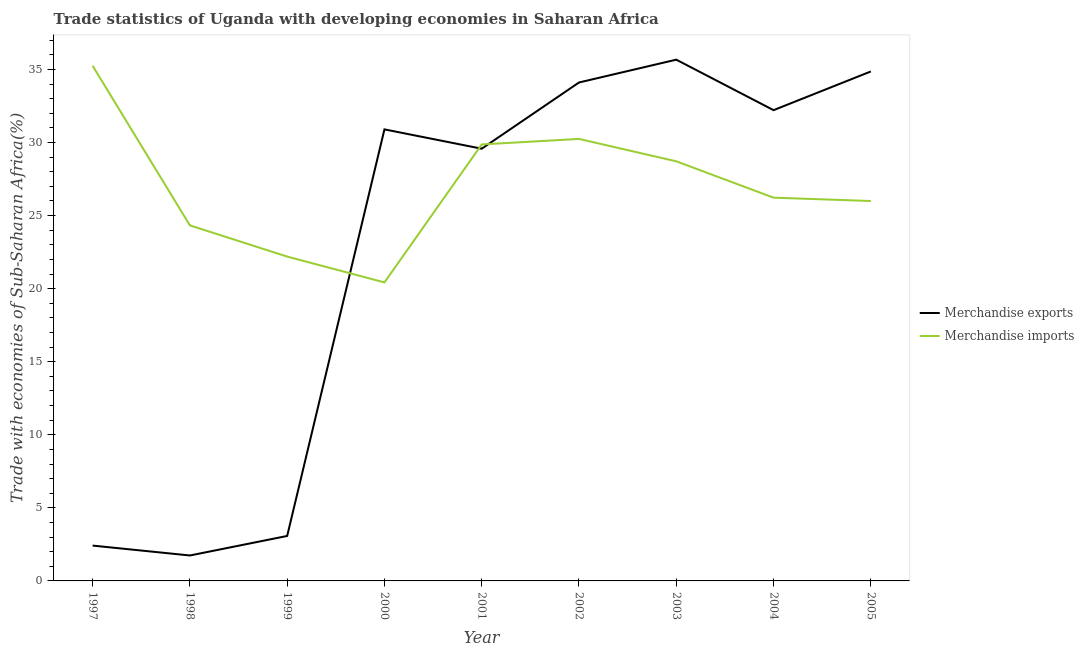How many different coloured lines are there?
Keep it short and to the point. 2. Does the line corresponding to merchandise imports intersect with the line corresponding to merchandise exports?
Make the answer very short. Yes. What is the merchandise imports in 2002?
Give a very brief answer. 30.24. Across all years, what is the maximum merchandise imports?
Provide a succinct answer. 35.25. Across all years, what is the minimum merchandise exports?
Your response must be concise. 1.74. In which year was the merchandise imports maximum?
Ensure brevity in your answer.  1997. In which year was the merchandise imports minimum?
Offer a terse response. 2000. What is the total merchandise exports in the graph?
Your response must be concise. 204.54. What is the difference between the merchandise imports in 1998 and that in 2002?
Offer a very short reply. -5.92. What is the difference between the merchandise exports in 1998 and the merchandise imports in 2001?
Provide a short and direct response. -28.13. What is the average merchandise exports per year?
Make the answer very short. 22.73. In the year 2004, what is the difference between the merchandise exports and merchandise imports?
Make the answer very short. 5.99. In how many years, is the merchandise imports greater than 7 %?
Give a very brief answer. 9. What is the ratio of the merchandise imports in 2001 to that in 2005?
Offer a very short reply. 1.15. What is the difference between the highest and the second highest merchandise exports?
Offer a terse response. 0.81. What is the difference between the highest and the lowest merchandise imports?
Your answer should be compact. 14.82. Does the merchandise imports monotonically increase over the years?
Provide a succinct answer. No. Is the merchandise imports strictly greater than the merchandise exports over the years?
Offer a very short reply. No. Is the merchandise imports strictly less than the merchandise exports over the years?
Give a very brief answer. No. How many years are there in the graph?
Ensure brevity in your answer.  9. What is the difference between two consecutive major ticks on the Y-axis?
Provide a succinct answer. 5. Are the values on the major ticks of Y-axis written in scientific E-notation?
Keep it short and to the point. No. Does the graph contain grids?
Your answer should be very brief. No. Where does the legend appear in the graph?
Ensure brevity in your answer.  Center right. How many legend labels are there?
Your answer should be very brief. 2. What is the title of the graph?
Provide a succinct answer. Trade statistics of Uganda with developing economies in Saharan Africa. What is the label or title of the X-axis?
Your response must be concise. Year. What is the label or title of the Y-axis?
Your response must be concise. Trade with economies of Sub-Saharan Africa(%). What is the Trade with economies of Sub-Saharan Africa(%) in Merchandise exports in 1997?
Your response must be concise. 2.42. What is the Trade with economies of Sub-Saharan Africa(%) in Merchandise imports in 1997?
Ensure brevity in your answer.  35.25. What is the Trade with economies of Sub-Saharan Africa(%) in Merchandise exports in 1998?
Offer a very short reply. 1.74. What is the Trade with economies of Sub-Saharan Africa(%) of Merchandise imports in 1998?
Give a very brief answer. 24.33. What is the Trade with economies of Sub-Saharan Africa(%) of Merchandise exports in 1999?
Give a very brief answer. 3.08. What is the Trade with economies of Sub-Saharan Africa(%) in Merchandise imports in 1999?
Make the answer very short. 22.19. What is the Trade with economies of Sub-Saharan Africa(%) in Merchandise exports in 2000?
Offer a very short reply. 30.9. What is the Trade with economies of Sub-Saharan Africa(%) in Merchandise imports in 2000?
Ensure brevity in your answer.  20.43. What is the Trade with economies of Sub-Saharan Africa(%) in Merchandise exports in 2001?
Provide a succinct answer. 29.57. What is the Trade with economies of Sub-Saharan Africa(%) in Merchandise imports in 2001?
Offer a very short reply. 29.87. What is the Trade with economies of Sub-Saharan Africa(%) of Merchandise exports in 2002?
Offer a very short reply. 34.1. What is the Trade with economies of Sub-Saharan Africa(%) of Merchandise imports in 2002?
Keep it short and to the point. 30.24. What is the Trade with economies of Sub-Saharan Africa(%) in Merchandise exports in 2003?
Give a very brief answer. 35.67. What is the Trade with economies of Sub-Saharan Africa(%) of Merchandise imports in 2003?
Offer a terse response. 28.71. What is the Trade with economies of Sub-Saharan Africa(%) in Merchandise exports in 2004?
Keep it short and to the point. 32.21. What is the Trade with economies of Sub-Saharan Africa(%) of Merchandise imports in 2004?
Ensure brevity in your answer.  26.22. What is the Trade with economies of Sub-Saharan Africa(%) of Merchandise exports in 2005?
Keep it short and to the point. 34.86. What is the Trade with economies of Sub-Saharan Africa(%) in Merchandise imports in 2005?
Offer a terse response. 25.99. Across all years, what is the maximum Trade with economies of Sub-Saharan Africa(%) of Merchandise exports?
Your response must be concise. 35.67. Across all years, what is the maximum Trade with economies of Sub-Saharan Africa(%) of Merchandise imports?
Your answer should be very brief. 35.25. Across all years, what is the minimum Trade with economies of Sub-Saharan Africa(%) of Merchandise exports?
Your answer should be very brief. 1.74. Across all years, what is the minimum Trade with economies of Sub-Saharan Africa(%) in Merchandise imports?
Offer a very short reply. 20.43. What is the total Trade with economies of Sub-Saharan Africa(%) in Merchandise exports in the graph?
Give a very brief answer. 204.54. What is the total Trade with economies of Sub-Saharan Africa(%) in Merchandise imports in the graph?
Keep it short and to the point. 243.23. What is the difference between the Trade with economies of Sub-Saharan Africa(%) of Merchandise exports in 1997 and that in 1998?
Make the answer very short. 0.68. What is the difference between the Trade with economies of Sub-Saharan Africa(%) of Merchandise imports in 1997 and that in 1998?
Give a very brief answer. 10.92. What is the difference between the Trade with economies of Sub-Saharan Africa(%) in Merchandise exports in 1997 and that in 1999?
Make the answer very short. -0.66. What is the difference between the Trade with economies of Sub-Saharan Africa(%) in Merchandise imports in 1997 and that in 1999?
Provide a short and direct response. 13.05. What is the difference between the Trade with economies of Sub-Saharan Africa(%) in Merchandise exports in 1997 and that in 2000?
Your answer should be compact. -28.48. What is the difference between the Trade with economies of Sub-Saharan Africa(%) in Merchandise imports in 1997 and that in 2000?
Provide a succinct answer. 14.82. What is the difference between the Trade with economies of Sub-Saharan Africa(%) in Merchandise exports in 1997 and that in 2001?
Your response must be concise. -27.16. What is the difference between the Trade with economies of Sub-Saharan Africa(%) of Merchandise imports in 1997 and that in 2001?
Your response must be concise. 5.38. What is the difference between the Trade with economies of Sub-Saharan Africa(%) of Merchandise exports in 1997 and that in 2002?
Provide a succinct answer. -31.69. What is the difference between the Trade with economies of Sub-Saharan Africa(%) in Merchandise imports in 1997 and that in 2002?
Make the answer very short. 5. What is the difference between the Trade with economies of Sub-Saharan Africa(%) of Merchandise exports in 1997 and that in 2003?
Your answer should be compact. -33.25. What is the difference between the Trade with economies of Sub-Saharan Africa(%) of Merchandise imports in 1997 and that in 2003?
Your response must be concise. 6.54. What is the difference between the Trade with economies of Sub-Saharan Africa(%) in Merchandise exports in 1997 and that in 2004?
Your answer should be compact. -29.79. What is the difference between the Trade with economies of Sub-Saharan Africa(%) of Merchandise imports in 1997 and that in 2004?
Offer a very short reply. 9.02. What is the difference between the Trade with economies of Sub-Saharan Africa(%) in Merchandise exports in 1997 and that in 2005?
Make the answer very short. -32.44. What is the difference between the Trade with economies of Sub-Saharan Africa(%) of Merchandise imports in 1997 and that in 2005?
Provide a short and direct response. 9.25. What is the difference between the Trade with economies of Sub-Saharan Africa(%) in Merchandise exports in 1998 and that in 1999?
Keep it short and to the point. -1.34. What is the difference between the Trade with economies of Sub-Saharan Africa(%) in Merchandise imports in 1998 and that in 1999?
Keep it short and to the point. 2.13. What is the difference between the Trade with economies of Sub-Saharan Africa(%) in Merchandise exports in 1998 and that in 2000?
Give a very brief answer. -29.16. What is the difference between the Trade with economies of Sub-Saharan Africa(%) of Merchandise imports in 1998 and that in 2000?
Provide a short and direct response. 3.9. What is the difference between the Trade with economies of Sub-Saharan Africa(%) in Merchandise exports in 1998 and that in 2001?
Your answer should be very brief. -27.83. What is the difference between the Trade with economies of Sub-Saharan Africa(%) in Merchandise imports in 1998 and that in 2001?
Your answer should be very brief. -5.54. What is the difference between the Trade with economies of Sub-Saharan Africa(%) in Merchandise exports in 1998 and that in 2002?
Offer a very short reply. -32.36. What is the difference between the Trade with economies of Sub-Saharan Africa(%) of Merchandise imports in 1998 and that in 2002?
Keep it short and to the point. -5.92. What is the difference between the Trade with economies of Sub-Saharan Africa(%) of Merchandise exports in 1998 and that in 2003?
Ensure brevity in your answer.  -33.93. What is the difference between the Trade with economies of Sub-Saharan Africa(%) of Merchandise imports in 1998 and that in 2003?
Your response must be concise. -4.38. What is the difference between the Trade with economies of Sub-Saharan Africa(%) in Merchandise exports in 1998 and that in 2004?
Provide a short and direct response. -30.47. What is the difference between the Trade with economies of Sub-Saharan Africa(%) of Merchandise imports in 1998 and that in 2004?
Your answer should be compact. -1.9. What is the difference between the Trade with economies of Sub-Saharan Africa(%) in Merchandise exports in 1998 and that in 2005?
Provide a succinct answer. -33.12. What is the difference between the Trade with economies of Sub-Saharan Africa(%) in Merchandise imports in 1998 and that in 2005?
Offer a very short reply. -1.67. What is the difference between the Trade with economies of Sub-Saharan Africa(%) of Merchandise exports in 1999 and that in 2000?
Provide a short and direct response. -27.82. What is the difference between the Trade with economies of Sub-Saharan Africa(%) in Merchandise imports in 1999 and that in 2000?
Keep it short and to the point. 1.77. What is the difference between the Trade with economies of Sub-Saharan Africa(%) in Merchandise exports in 1999 and that in 2001?
Provide a succinct answer. -26.5. What is the difference between the Trade with economies of Sub-Saharan Africa(%) of Merchandise imports in 1999 and that in 2001?
Offer a very short reply. -7.67. What is the difference between the Trade with economies of Sub-Saharan Africa(%) of Merchandise exports in 1999 and that in 2002?
Ensure brevity in your answer.  -31.03. What is the difference between the Trade with economies of Sub-Saharan Africa(%) of Merchandise imports in 1999 and that in 2002?
Your response must be concise. -8.05. What is the difference between the Trade with economies of Sub-Saharan Africa(%) of Merchandise exports in 1999 and that in 2003?
Your response must be concise. -32.59. What is the difference between the Trade with economies of Sub-Saharan Africa(%) of Merchandise imports in 1999 and that in 2003?
Provide a succinct answer. -6.52. What is the difference between the Trade with economies of Sub-Saharan Africa(%) in Merchandise exports in 1999 and that in 2004?
Your answer should be compact. -29.13. What is the difference between the Trade with economies of Sub-Saharan Africa(%) of Merchandise imports in 1999 and that in 2004?
Your answer should be very brief. -4.03. What is the difference between the Trade with economies of Sub-Saharan Africa(%) of Merchandise exports in 1999 and that in 2005?
Offer a terse response. -31.78. What is the difference between the Trade with economies of Sub-Saharan Africa(%) of Merchandise imports in 1999 and that in 2005?
Ensure brevity in your answer.  -3.8. What is the difference between the Trade with economies of Sub-Saharan Africa(%) of Merchandise exports in 2000 and that in 2001?
Provide a succinct answer. 1.32. What is the difference between the Trade with economies of Sub-Saharan Africa(%) in Merchandise imports in 2000 and that in 2001?
Ensure brevity in your answer.  -9.44. What is the difference between the Trade with economies of Sub-Saharan Africa(%) in Merchandise exports in 2000 and that in 2002?
Keep it short and to the point. -3.21. What is the difference between the Trade with economies of Sub-Saharan Africa(%) in Merchandise imports in 2000 and that in 2002?
Provide a succinct answer. -9.82. What is the difference between the Trade with economies of Sub-Saharan Africa(%) of Merchandise exports in 2000 and that in 2003?
Your answer should be very brief. -4.77. What is the difference between the Trade with economies of Sub-Saharan Africa(%) of Merchandise imports in 2000 and that in 2003?
Provide a succinct answer. -8.29. What is the difference between the Trade with economies of Sub-Saharan Africa(%) in Merchandise exports in 2000 and that in 2004?
Give a very brief answer. -1.31. What is the difference between the Trade with economies of Sub-Saharan Africa(%) in Merchandise imports in 2000 and that in 2004?
Provide a succinct answer. -5.8. What is the difference between the Trade with economies of Sub-Saharan Africa(%) of Merchandise exports in 2000 and that in 2005?
Your answer should be compact. -3.96. What is the difference between the Trade with economies of Sub-Saharan Africa(%) in Merchandise imports in 2000 and that in 2005?
Your answer should be compact. -5.57. What is the difference between the Trade with economies of Sub-Saharan Africa(%) of Merchandise exports in 2001 and that in 2002?
Your response must be concise. -4.53. What is the difference between the Trade with economies of Sub-Saharan Africa(%) of Merchandise imports in 2001 and that in 2002?
Keep it short and to the point. -0.38. What is the difference between the Trade with economies of Sub-Saharan Africa(%) of Merchandise exports in 2001 and that in 2003?
Make the answer very short. -6.09. What is the difference between the Trade with economies of Sub-Saharan Africa(%) in Merchandise imports in 2001 and that in 2003?
Offer a very short reply. 1.16. What is the difference between the Trade with economies of Sub-Saharan Africa(%) in Merchandise exports in 2001 and that in 2004?
Ensure brevity in your answer.  -2.64. What is the difference between the Trade with economies of Sub-Saharan Africa(%) in Merchandise imports in 2001 and that in 2004?
Ensure brevity in your answer.  3.64. What is the difference between the Trade with economies of Sub-Saharan Africa(%) in Merchandise exports in 2001 and that in 2005?
Make the answer very short. -5.29. What is the difference between the Trade with economies of Sub-Saharan Africa(%) in Merchandise imports in 2001 and that in 2005?
Your response must be concise. 3.87. What is the difference between the Trade with economies of Sub-Saharan Africa(%) of Merchandise exports in 2002 and that in 2003?
Provide a short and direct response. -1.56. What is the difference between the Trade with economies of Sub-Saharan Africa(%) of Merchandise imports in 2002 and that in 2003?
Provide a short and direct response. 1.53. What is the difference between the Trade with economies of Sub-Saharan Africa(%) of Merchandise exports in 2002 and that in 2004?
Offer a terse response. 1.89. What is the difference between the Trade with economies of Sub-Saharan Africa(%) of Merchandise imports in 2002 and that in 2004?
Provide a succinct answer. 4.02. What is the difference between the Trade with economies of Sub-Saharan Africa(%) of Merchandise exports in 2002 and that in 2005?
Provide a succinct answer. -0.75. What is the difference between the Trade with economies of Sub-Saharan Africa(%) of Merchandise imports in 2002 and that in 2005?
Your answer should be very brief. 4.25. What is the difference between the Trade with economies of Sub-Saharan Africa(%) in Merchandise exports in 2003 and that in 2004?
Offer a very short reply. 3.45. What is the difference between the Trade with economies of Sub-Saharan Africa(%) of Merchandise imports in 2003 and that in 2004?
Provide a succinct answer. 2.49. What is the difference between the Trade with economies of Sub-Saharan Africa(%) of Merchandise exports in 2003 and that in 2005?
Offer a terse response. 0.81. What is the difference between the Trade with economies of Sub-Saharan Africa(%) in Merchandise imports in 2003 and that in 2005?
Ensure brevity in your answer.  2.72. What is the difference between the Trade with economies of Sub-Saharan Africa(%) of Merchandise exports in 2004 and that in 2005?
Your answer should be very brief. -2.65. What is the difference between the Trade with economies of Sub-Saharan Africa(%) in Merchandise imports in 2004 and that in 2005?
Provide a short and direct response. 0.23. What is the difference between the Trade with economies of Sub-Saharan Africa(%) in Merchandise exports in 1997 and the Trade with economies of Sub-Saharan Africa(%) in Merchandise imports in 1998?
Keep it short and to the point. -21.91. What is the difference between the Trade with economies of Sub-Saharan Africa(%) of Merchandise exports in 1997 and the Trade with economies of Sub-Saharan Africa(%) of Merchandise imports in 1999?
Make the answer very short. -19.77. What is the difference between the Trade with economies of Sub-Saharan Africa(%) of Merchandise exports in 1997 and the Trade with economies of Sub-Saharan Africa(%) of Merchandise imports in 2000?
Keep it short and to the point. -18.01. What is the difference between the Trade with economies of Sub-Saharan Africa(%) in Merchandise exports in 1997 and the Trade with economies of Sub-Saharan Africa(%) in Merchandise imports in 2001?
Give a very brief answer. -27.45. What is the difference between the Trade with economies of Sub-Saharan Africa(%) of Merchandise exports in 1997 and the Trade with economies of Sub-Saharan Africa(%) of Merchandise imports in 2002?
Keep it short and to the point. -27.82. What is the difference between the Trade with economies of Sub-Saharan Africa(%) in Merchandise exports in 1997 and the Trade with economies of Sub-Saharan Africa(%) in Merchandise imports in 2003?
Keep it short and to the point. -26.29. What is the difference between the Trade with economies of Sub-Saharan Africa(%) of Merchandise exports in 1997 and the Trade with economies of Sub-Saharan Africa(%) of Merchandise imports in 2004?
Your response must be concise. -23.81. What is the difference between the Trade with economies of Sub-Saharan Africa(%) in Merchandise exports in 1997 and the Trade with economies of Sub-Saharan Africa(%) in Merchandise imports in 2005?
Keep it short and to the point. -23.58. What is the difference between the Trade with economies of Sub-Saharan Africa(%) in Merchandise exports in 1998 and the Trade with economies of Sub-Saharan Africa(%) in Merchandise imports in 1999?
Keep it short and to the point. -20.45. What is the difference between the Trade with economies of Sub-Saharan Africa(%) of Merchandise exports in 1998 and the Trade with economies of Sub-Saharan Africa(%) of Merchandise imports in 2000?
Your answer should be very brief. -18.68. What is the difference between the Trade with economies of Sub-Saharan Africa(%) in Merchandise exports in 1998 and the Trade with economies of Sub-Saharan Africa(%) in Merchandise imports in 2001?
Your response must be concise. -28.13. What is the difference between the Trade with economies of Sub-Saharan Africa(%) in Merchandise exports in 1998 and the Trade with economies of Sub-Saharan Africa(%) in Merchandise imports in 2002?
Offer a very short reply. -28.5. What is the difference between the Trade with economies of Sub-Saharan Africa(%) in Merchandise exports in 1998 and the Trade with economies of Sub-Saharan Africa(%) in Merchandise imports in 2003?
Offer a terse response. -26.97. What is the difference between the Trade with economies of Sub-Saharan Africa(%) of Merchandise exports in 1998 and the Trade with economies of Sub-Saharan Africa(%) of Merchandise imports in 2004?
Give a very brief answer. -24.48. What is the difference between the Trade with economies of Sub-Saharan Africa(%) in Merchandise exports in 1998 and the Trade with economies of Sub-Saharan Africa(%) in Merchandise imports in 2005?
Your answer should be very brief. -24.25. What is the difference between the Trade with economies of Sub-Saharan Africa(%) of Merchandise exports in 1999 and the Trade with economies of Sub-Saharan Africa(%) of Merchandise imports in 2000?
Provide a succinct answer. -17.35. What is the difference between the Trade with economies of Sub-Saharan Africa(%) of Merchandise exports in 1999 and the Trade with economies of Sub-Saharan Africa(%) of Merchandise imports in 2001?
Offer a terse response. -26.79. What is the difference between the Trade with economies of Sub-Saharan Africa(%) of Merchandise exports in 1999 and the Trade with economies of Sub-Saharan Africa(%) of Merchandise imports in 2002?
Your answer should be very brief. -27.17. What is the difference between the Trade with economies of Sub-Saharan Africa(%) of Merchandise exports in 1999 and the Trade with economies of Sub-Saharan Africa(%) of Merchandise imports in 2003?
Ensure brevity in your answer.  -25.63. What is the difference between the Trade with economies of Sub-Saharan Africa(%) in Merchandise exports in 1999 and the Trade with economies of Sub-Saharan Africa(%) in Merchandise imports in 2004?
Offer a terse response. -23.15. What is the difference between the Trade with economies of Sub-Saharan Africa(%) in Merchandise exports in 1999 and the Trade with economies of Sub-Saharan Africa(%) in Merchandise imports in 2005?
Your response must be concise. -22.92. What is the difference between the Trade with economies of Sub-Saharan Africa(%) in Merchandise exports in 2000 and the Trade with economies of Sub-Saharan Africa(%) in Merchandise imports in 2001?
Provide a short and direct response. 1.03. What is the difference between the Trade with economies of Sub-Saharan Africa(%) of Merchandise exports in 2000 and the Trade with economies of Sub-Saharan Africa(%) of Merchandise imports in 2002?
Your answer should be compact. 0.65. What is the difference between the Trade with economies of Sub-Saharan Africa(%) in Merchandise exports in 2000 and the Trade with economies of Sub-Saharan Africa(%) in Merchandise imports in 2003?
Make the answer very short. 2.19. What is the difference between the Trade with economies of Sub-Saharan Africa(%) of Merchandise exports in 2000 and the Trade with economies of Sub-Saharan Africa(%) of Merchandise imports in 2004?
Your response must be concise. 4.67. What is the difference between the Trade with economies of Sub-Saharan Africa(%) in Merchandise exports in 2000 and the Trade with economies of Sub-Saharan Africa(%) in Merchandise imports in 2005?
Your answer should be compact. 4.9. What is the difference between the Trade with economies of Sub-Saharan Africa(%) of Merchandise exports in 2001 and the Trade with economies of Sub-Saharan Africa(%) of Merchandise imports in 2002?
Give a very brief answer. -0.67. What is the difference between the Trade with economies of Sub-Saharan Africa(%) in Merchandise exports in 2001 and the Trade with economies of Sub-Saharan Africa(%) in Merchandise imports in 2003?
Your answer should be very brief. 0.86. What is the difference between the Trade with economies of Sub-Saharan Africa(%) of Merchandise exports in 2001 and the Trade with economies of Sub-Saharan Africa(%) of Merchandise imports in 2004?
Make the answer very short. 3.35. What is the difference between the Trade with economies of Sub-Saharan Africa(%) of Merchandise exports in 2001 and the Trade with economies of Sub-Saharan Africa(%) of Merchandise imports in 2005?
Your response must be concise. 3.58. What is the difference between the Trade with economies of Sub-Saharan Africa(%) of Merchandise exports in 2002 and the Trade with economies of Sub-Saharan Africa(%) of Merchandise imports in 2003?
Give a very brief answer. 5.39. What is the difference between the Trade with economies of Sub-Saharan Africa(%) in Merchandise exports in 2002 and the Trade with economies of Sub-Saharan Africa(%) in Merchandise imports in 2004?
Provide a short and direct response. 7.88. What is the difference between the Trade with economies of Sub-Saharan Africa(%) in Merchandise exports in 2002 and the Trade with economies of Sub-Saharan Africa(%) in Merchandise imports in 2005?
Your answer should be very brief. 8.11. What is the difference between the Trade with economies of Sub-Saharan Africa(%) of Merchandise exports in 2003 and the Trade with economies of Sub-Saharan Africa(%) of Merchandise imports in 2004?
Offer a terse response. 9.44. What is the difference between the Trade with economies of Sub-Saharan Africa(%) in Merchandise exports in 2003 and the Trade with economies of Sub-Saharan Africa(%) in Merchandise imports in 2005?
Keep it short and to the point. 9.67. What is the difference between the Trade with economies of Sub-Saharan Africa(%) in Merchandise exports in 2004 and the Trade with economies of Sub-Saharan Africa(%) in Merchandise imports in 2005?
Ensure brevity in your answer.  6.22. What is the average Trade with economies of Sub-Saharan Africa(%) of Merchandise exports per year?
Provide a short and direct response. 22.73. What is the average Trade with economies of Sub-Saharan Africa(%) of Merchandise imports per year?
Offer a terse response. 27.03. In the year 1997, what is the difference between the Trade with economies of Sub-Saharan Africa(%) of Merchandise exports and Trade with economies of Sub-Saharan Africa(%) of Merchandise imports?
Make the answer very short. -32.83. In the year 1998, what is the difference between the Trade with economies of Sub-Saharan Africa(%) in Merchandise exports and Trade with economies of Sub-Saharan Africa(%) in Merchandise imports?
Provide a short and direct response. -22.59. In the year 1999, what is the difference between the Trade with economies of Sub-Saharan Africa(%) of Merchandise exports and Trade with economies of Sub-Saharan Africa(%) of Merchandise imports?
Ensure brevity in your answer.  -19.12. In the year 2000, what is the difference between the Trade with economies of Sub-Saharan Africa(%) in Merchandise exports and Trade with economies of Sub-Saharan Africa(%) in Merchandise imports?
Ensure brevity in your answer.  10.47. In the year 2001, what is the difference between the Trade with economies of Sub-Saharan Africa(%) of Merchandise exports and Trade with economies of Sub-Saharan Africa(%) of Merchandise imports?
Give a very brief answer. -0.29. In the year 2002, what is the difference between the Trade with economies of Sub-Saharan Africa(%) of Merchandise exports and Trade with economies of Sub-Saharan Africa(%) of Merchandise imports?
Provide a succinct answer. 3.86. In the year 2003, what is the difference between the Trade with economies of Sub-Saharan Africa(%) in Merchandise exports and Trade with economies of Sub-Saharan Africa(%) in Merchandise imports?
Your response must be concise. 6.96. In the year 2004, what is the difference between the Trade with economies of Sub-Saharan Africa(%) in Merchandise exports and Trade with economies of Sub-Saharan Africa(%) in Merchandise imports?
Keep it short and to the point. 5.99. In the year 2005, what is the difference between the Trade with economies of Sub-Saharan Africa(%) of Merchandise exports and Trade with economies of Sub-Saharan Africa(%) of Merchandise imports?
Provide a succinct answer. 8.86. What is the ratio of the Trade with economies of Sub-Saharan Africa(%) of Merchandise exports in 1997 to that in 1998?
Your answer should be compact. 1.39. What is the ratio of the Trade with economies of Sub-Saharan Africa(%) in Merchandise imports in 1997 to that in 1998?
Offer a terse response. 1.45. What is the ratio of the Trade with economies of Sub-Saharan Africa(%) in Merchandise exports in 1997 to that in 1999?
Ensure brevity in your answer.  0.79. What is the ratio of the Trade with economies of Sub-Saharan Africa(%) in Merchandise imports in 1997 to that in 1999?
Offer a very short reply. 1.59. What is the ratio of the Trade with economies of Sub-Saharan Africa(%) in Merchandise exports in 1997 to that in 2000?
Offer a terse response. 0.08. What is the ratio of the Trade with economies of Sub-Saharan Africa(%) of Merchandise imports in 1997 to that in 2000?
Your response must be concise. 1.73. What is the ratio of the Trade with economies of Sub-Saharan Africa(%) in Merchandise exports in 1997 to that in 2001?
Provide a short and direct response. 0.08. What is the ratio of the Trade with economies of Sub-Saharan Africa(%) of Merchandise imports in 1997 to that in 2001?
Your response must be concise. 1.18. What is the ratio of the Trade with economies of Sub-Saharan Africa(%) of Merchandise exports in 1997 to that in 2002?
Provide a succinct answer. 0.07. What is the ratio of the Trade with economies of Sub-Saharan Africa(%) in Merchandise imports in 1997 to that in 2002?
Ensure brevity in your answer.  1.17. What is the ratio of the Trade with economies of Sub-Saharan Africa(%) of Merchandise exports in 1997 to that in 2003?
Make the answer very short. 0.07. What is the ratio of the Trade with economies of Sub-Saharan Africa(%) in Merchandise imports in 1997 to that in 2003?
Provide a succinct answer. 1.23. What is the ratio of the Trade with economies of Sub-Saharan Africa(%) of Merchandise exports in 1997 to that in 2004?
Offer a very short reply. 0.08. What is the ratio of the Trade with economies of Sub-Saharan Africa(%) in Merchandise imports in 1997 to that in 2004?
Your answer should be very brief. 1.34. What is the ratio of the Trade with economies of Sub-Saharan Africa(%) in Merchandise exports in 1997 to that in 2005?
Provide a short and direct response. 0.07. What is the ratio of the Trade with economies of Sub-Saharan Africa(%) in Merchandise imports in 1997 to that in 2005?
Provide a succinct answer. 1.36. What is the ratio of the Trade with economies of Sub-Saharan Africa(%) in Merchandise exports in 1998 to that in 1999?
Your answer should be very brief. 0.57. What is the ratio of the Trade with economies of Sub-Saharan Africa(%) of Merchandise imports in 1998 to that in 1999?
Keep it short and to the point. 1.1. What is the ratio of the Trade with economies of Sub-Saharan Africa(%) of Merchandise exports in 1998 to that in 2000?
Offer a very short reply. 0.06. What is the ratio of the Trade with economies of Sub-Saharan Africa(%) in Merchandise imports in 1998 to that in 2000?
Offer a terse response. 1.19. What is the ratio of the Trade with economies of Sub-Saharan Africa(%) in Merchandise exports in 1998 to that in 2001?
Keep it short and to the point. 0.06. What is the ratio of the Trade with economies of Sub-Saharan Africa(%) in Merchandise imports in 1998 to that in 2001?
Make the answer very short. 0.81. What is the ratio of the Trade with economies of Sub-Saharan Africa(%) of Merchandise exports in 1998 to that in 2002?
Give a very brief answer. 0.05. What is the ratio of the Trade with economies of Sub-Saharan Africa(%) in Merchandise imports in 1998 to that in 2002?
Your answer should be compact. 0.8. What is the ratio of the Trade with economies of Sub-Saharan Africa(%) in Merchandise exports in 1998 to that in 2003?
Your response must be concise. 0.05. What is the ratio of the Trade with economies of Sub-Saharan Africa(%) of Merchandise imports in 1998 to that in 2003?
Offer a very short reply. 0.85. What is the ratio of the Trade with economies of Sub-Saharan Africa(%) in Merchandise exports in 1998 to that in 2004?
Ensure brevity in your answer.  0.05. What is the ratio of the Trade with economies of Sub-Saharan Africa(%) in Merchandise imports in 1998 to that in 2004?
Make the answer very short. 0.93. What is the ratio of the Trade with economies of Sub-Saharan Africa(%) in Merchandise exports in 1998 to that in 2005?
Make the answer very short. 0.05. What is the ratio of the Trade with economies of Sub-Saharan Africa(%) in Merchandise imports in 1998 to that in 2005?
Make the answer very short. 0.94. What is the ratio of the Trade with economies of Sub-Saharan Africa(%) of Merchandise exports in 1999 to that in 2000?
Keep it short and to the point. 0.1. What is the ratio of the Trade with economies of Sub-Saharan Africa(%) of Merchandise imports in 1999 to that in 2000?
Offer a terse response. 1.09. What is the ratio of the Trade with economies of Sub-Saharan Africa(%) of Merchandise exports in 1999 to that in 2001?
Provide a succinct answer. 0.1. What is the ratio of the Trade with economies of Sub-Saharan Africa(%) of Merchandise imports in 1999 to that in 2001?
Make the answer very short. 0.74. What is the ratio of the Trade with economies of Sub-Saharan Africa(%) of Merchandise exports in 1999 to that in 2002?
Ensure brevity in your answer.  0.09. What is the ratio of the Trade with economies of Sub-Saharan Africa(%) in Merchandise imports in 1999 to that in 2002?
Give a very brief answer. 0.73. What is the ratio of the Trade with economies of Sub-Saharan Africa(%) in Merchandise exports in 1999 to that in 2003?
Your answer should be very brief. 0.09. What is the ratio of the Trade with economies of Sub-Saharan Africa(%) of Merchandise imports in 1999 to that in 2003?
Offer a very short reply. 0.77. What is the ratio of the Trade with economies of Sub-Saharan Africa(%) in Merchandise exports in 1999 to that in 2004?
Give a very brief answer. 0.1. What is the ratio of the Trade with economies of Sub-Saharan Africa(%) of Merchandise imports in 1999 to that in 2004?
Keep it short and to the point. 0.85. What is the ratio of the Trade with economies of Sub-Saharan Africa(%) in Merchandise exports in 1999 to that in 2005?
Your answer should be compact. 0.09. What is the ratio of the Trade with economies of Sub-Saharan Africa(%) in Merchandise imports in 1999 to that in 2005?
Ensure brevity in your answer.  0.85. What is the ratio of the Trade with economies of Sub-Saharan Africa(%) in Merchandise exports in 2000 to that in 2001?
Keep it short and to the point. 1.04. What is the ratio of the Trade with economies of Sub-Saharan Africa(%) in Merchandise imports in 2000 to that in 2001?
Offer a very short reply. 0.68. What is the ratio of the Trade with economies of Sub-Saharan Africa(%) of Merchandise exports in 2000 to that in 2002?
Give a very brief answer. 0.91. What is the ratio of the Trade with economies of Sub-Saharan Africa(%) in Merchandise imports in 2000 to that in 2002?
Keep it short and to the point. 0.68. What is the ratio of the Trade with economies of Sub-Saharan Africa(%) of Merchandise exports in 2000 to that in 2003?
Your answer should be very brief. 0.87. What is the ratio of the Trade with economies of Sub-Saharan Africa(%) of Merchandise imports in 2000 to that in 2003?
Make the answer very short. 0.71. What is the ratio of the Trade with economies of Sub-Saharan Africa(%) in Merchandise exports in 2000 to that in 2004?
Your answer should be very brief. 0.96. What is the ratio of the Trade with economies of Sub-Saharan Africa(%) in Merchandise imports in 2000 to that in 2004?
Offer a terse response. 0.78. What is the ratio of the Trade with economies of Sub-Saharan Africa(%) of Merchandise exports in 2000 to that in 2005?
Provide a short and direct response. 0.89. What is the ratio of the Trade with economies of Sub-Saharan Africa(%) in Merchandise imports in 2000 to that in 2005?
Your answer should be compact. 0.79. What is the ratio of the Trade with economies of Sub-Saharan Africa(%) of Merchandise exports in 2001 to that in 2002?
Provide a succinct answer. 0.87. What is the ratio of the Trade with economies of Sub-Saharan Africa(%) in Merchandise imports in 2001 to that in 2002?
Your answer should be very brief. 0.99. What is the ratio of the Trade with economies of Sub-Saharan Africa(%) in Merchandise exports in 2001 to that in 2003?
Give a very brief answer. 0.83. What is the ratio of the Trade with economies of Sub-Saharan Africa(%) of Merchandise imports in 2001 to that in 2003?
Offer a terse response. 1.04. What is the ratio of the Trade with economies of Sub-Saharan Africa(%) in Merchandise exports in 2001 to that in 2004?
Your response must be concise. 0.92. What is the ratio of the Trade with economies of Sub-Saharan Africa(%) in Merchandise imports in 2001 to that in 2004?
Offer a terse response. 1.14. What is the ratio of the Trade with economies of Sub-Saharan Africa(%) of Merchandise exports in 2001 to that in 2005?
Provide a succinct answer. 0.85. What is the ratio of the Trade with economies of Sub-Saharan Africa(%) of Merchandise imports in 2001 to that in 2005?
Provide a short and direct response. 1.15. What is the ratio of the Trade with economies of Sub-Saharan Africa(%) of Merchandise exports in 2002 to that in 2003?
Ensure brevity in your answer.  0.96. What is the ratio of the Trade with economies of Sub-Saharan Africa(%) in Merchandise imports in 2002 to that in 2003?
Give a very brief answer. 1.05. What is the ratio of the Trade with economies of Sub-Saharan Africa(%) in Merchandise exports in 2002 to that in 2004?
Give a very brief answer. 1.06. What is the ratio of the Trade with economies of Sub-Saharan Africa(%) in Merchandise imports in 2002 to that in 2004?
Offer a very short reply. 1.15. What is the ratio of the Trade with economies of Sub-Saharan Africa(%) in Merchandise exports in 2002 to that in 2005?
Keep it short and to the point. 0.98. What is the ratio of the Trade with economies of Sub-Saharan Africa(%) of Merchandise imports in 2002 to that in 2005?
Make the answer very short. 1.16. What is the ratio of the Trade with economies of Sub-Saharan Africa(%) of Merchandise exports in 2003 to that in 2004?
Offer a terse response. 1.11. What is the ratio of the Trade with economies of Sub-Saharan Africa(%) in Merchandise imports in 2003 to that in 2004?
Keep it short and to the point. 1.09. What is the ratio of the Trade with economies of Sub-Saharan Africa(%) of Merchandise exports in 2003 to that in 2005?
Your answer should be very brief. 1.02. What is the ratio of the Trade with economies of Sub-Saharan Africa(%) in Merchandise imports in 2003 to that in 2005?
Your response must be concise. 1.1. What is the ratio of the Trade with economies of Sub-Saharan Africa(%) in Merchandise exports in 2004 to that in 2005?
Ensure brevity in your answer.  0.92. What is the ratio of the Trade with economies of Sub-Saharan Africa(%) in Merchandise imports in 2004 to that in 2005?
Provide a succinct answer. 1.01. What is the difference between the highest and the second highest Trade with economies of Sub-Saharan Africa(%) of Merchandise exports?
Give a very brief answer. 0.81. What is the difference between the highest and the second highest Trade with economies of Sub-Saharan Africa(%) in Merchandise imports?
Provide a short and direct response. 5. What is the difference between the highest and the lowest Trade with economies of Sub-Saharan Africa(%) of Merchandise exports?
Ensure brevity in your answer.  33.93. What is the difference between the highest and the lowest Trade with economies of Sub-Saharan Africa(%) in Merchandise imports?
Your response must be concise. 14.82. 